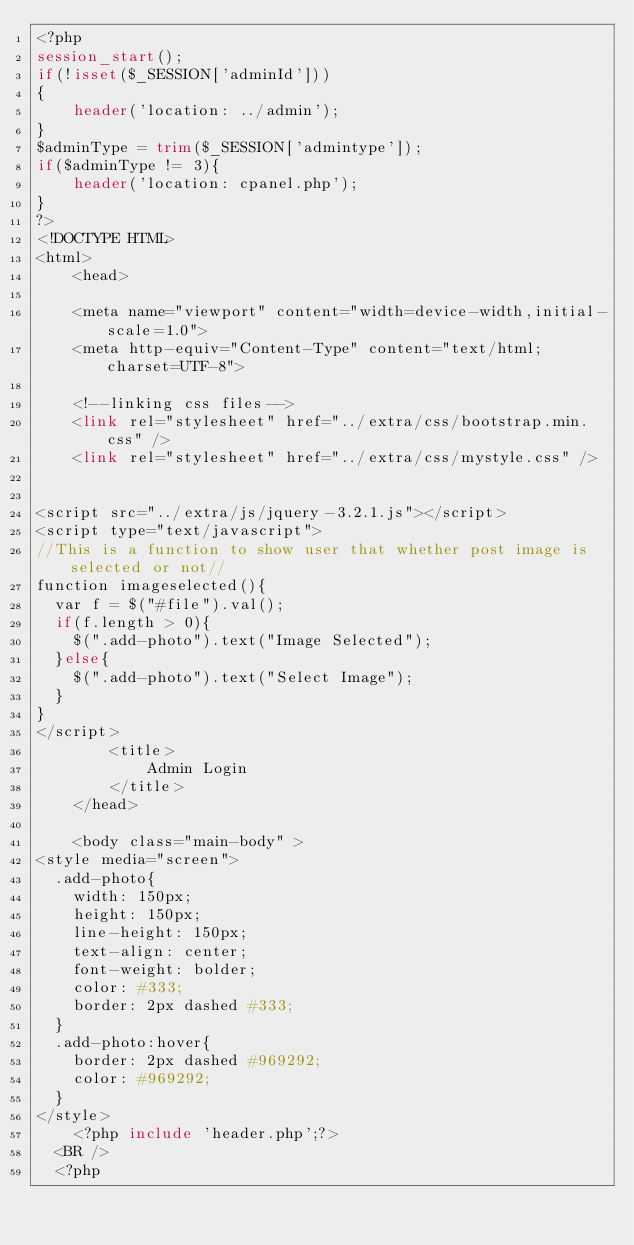<code> <loc_0><loc_0><loc_500><loc_500><_PHP_><?php
session_start();
if(!isset($_SESSION['adminId']))
{
	header('location: ../admin');
}
$adminType = trim($_SESSION['admintype']);
if($adminType != 3){
	header('location: cpanel.php');
}
?>
<!DOCTYPE HTML>
<html>
	<head>

	<meta name="viewport" content="width=device-width,initial-scale=1.0">
	<meta http-equiv="Content-Type" content="text/html; charset=UTF-8">

	<!--linking css files-->
	<link rel="stylesheet" href="../extra/css/bootstrap.min.css" />
	<link rel="stylesheet" href="../extra/css/mystyle.css" />


<script src="../extra/js/jquery-3.2.1.js"></script>
<script type="text/javascript">
//This is a function to show user that whether post image is selected or not//
function imageselected(){
  var f = $("#file").val();
  if(f.length > 0){
    $(".add-photo").text("Image Selected");
  }else{
    $(".add-photo").text("Select Image");
  }
}
</script>
		<title>
			Admin Login
		</title>
	</head>

	<body class="main-body" >
<style media="screen">
  .add-photo{
    width: 150px;
    height: 150px;
    line-height: 150px;
    text-align: center;
    font-weight: bolder;
    color: #333;
    border: 2px dashed #333;
  }
  .add-photo:hover{
    border: 2px dashed #969292;
    color: #969292;
  }
</style>
	<?php include 'header.php';?>
  <BR />
  <?php</code> 